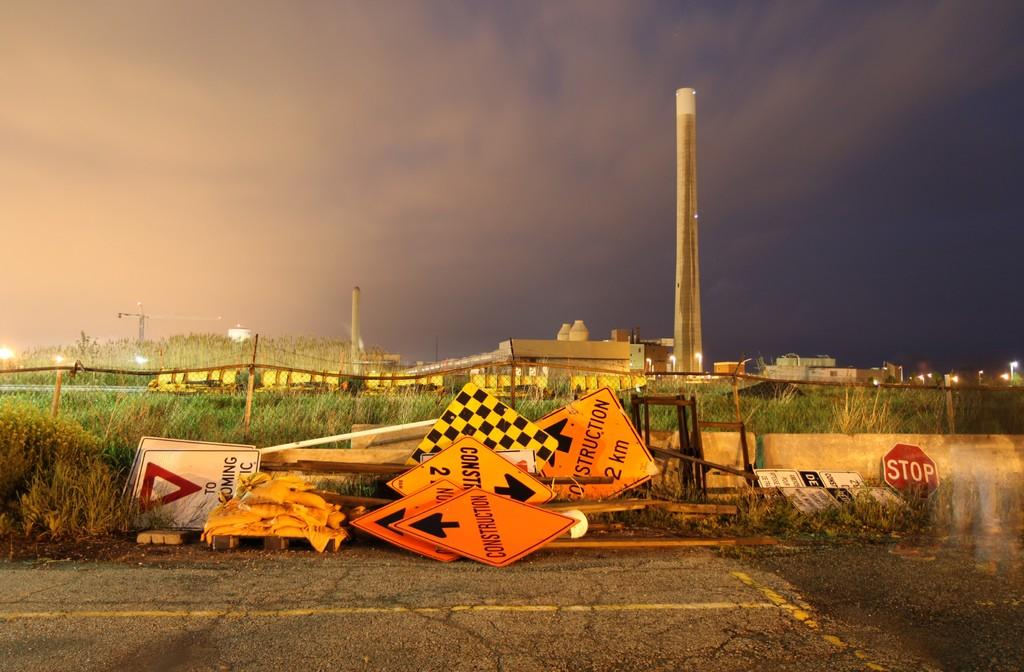<image>
Present a compact description of the photo's key features. an orange sign with the word construction on it 